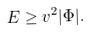<formula> <loc_0><loc_0><loc_500><loc_500>E \geq v ^ { 2 } | \Phi | .</formula> 